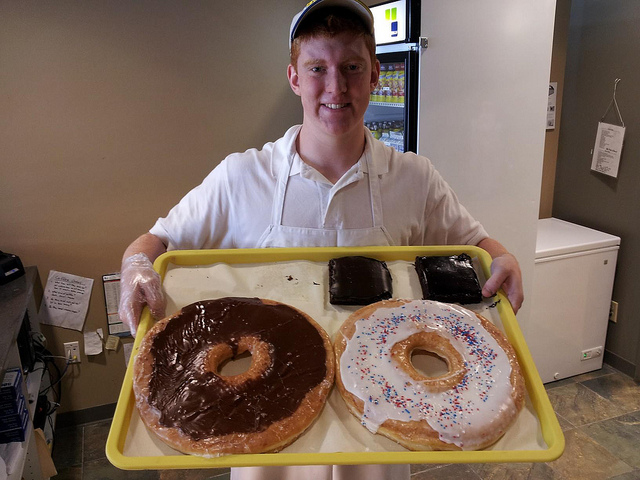What ingredients are typically used in making these pastries, and how does their size affect the baking process? These pastries typically contain flour, sugar, eggs, and other common baking ingredients. The larger size requires precise adjustments in baking time and temperature to achieve the right consistency without overbaking the outside or underbaking the inside. 